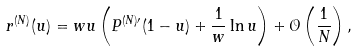Convert formula to latex. <formula><loc_0><loc_0><loc_500><loc_500>r ^ { ( N ) } ( u ) = w u \left ( P ^ { ( N ) \prime } ( 1 - u ) + \frac { 1 } { w } \ln u \right ) + \mathcal { O } \left ( \frac { 1 } { N } \right ) ,</formula> 